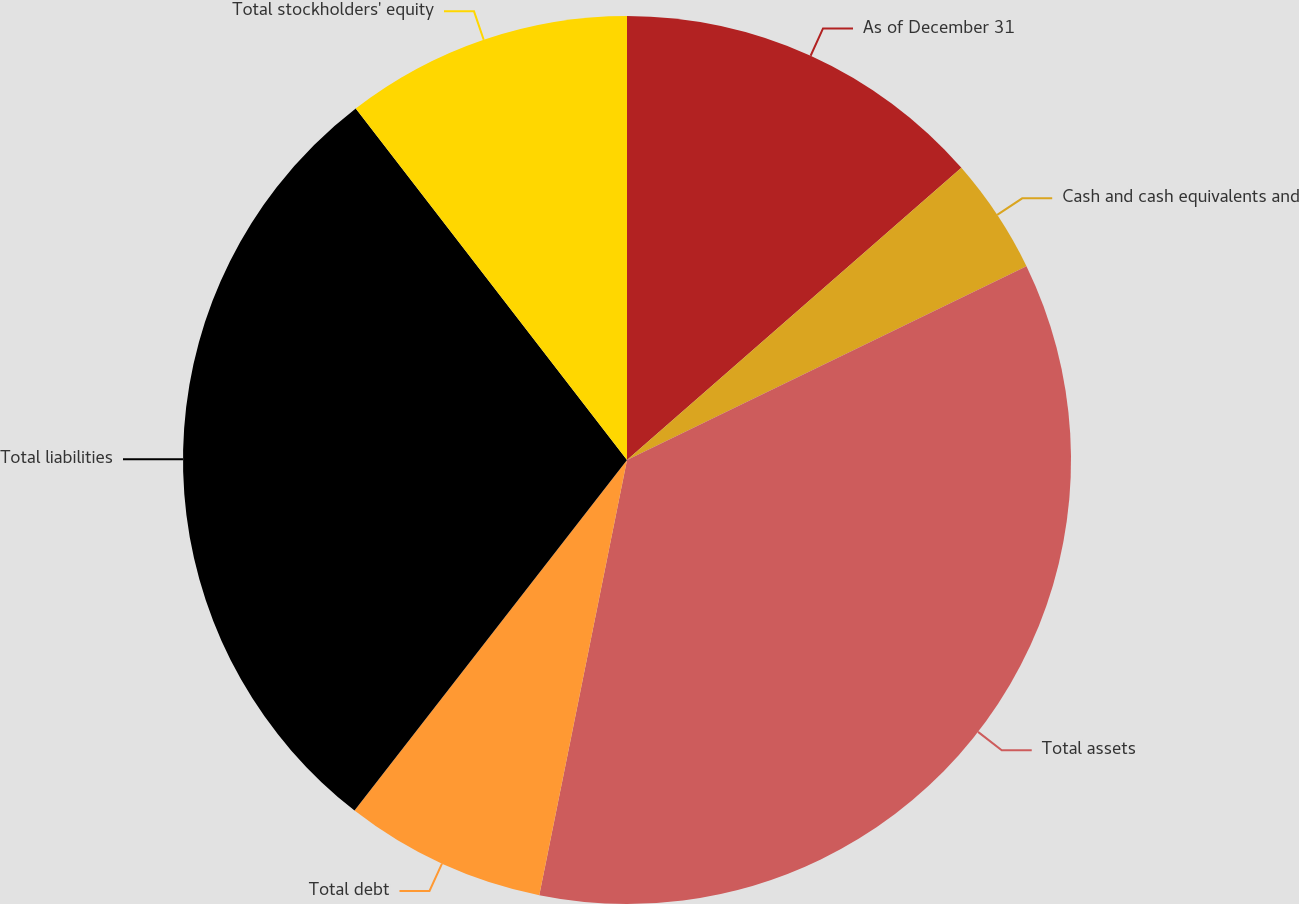Convert chart to OTSL. <chart><loc_0><loc_0><loc_500><loc_500><pie_chart><fcel>As of December 31<fcel>Cash and cash equivalents and<fcel>Total assets<fcel>Total debt<fcel>Total liabilities<fcel>Total stockholders' equity<nl><fcel>13.57%<fcel>4.24%<fcel>35.35%<fcel>7.35%<fcel>29.02%<fcel>10.46%<nl></chart> 